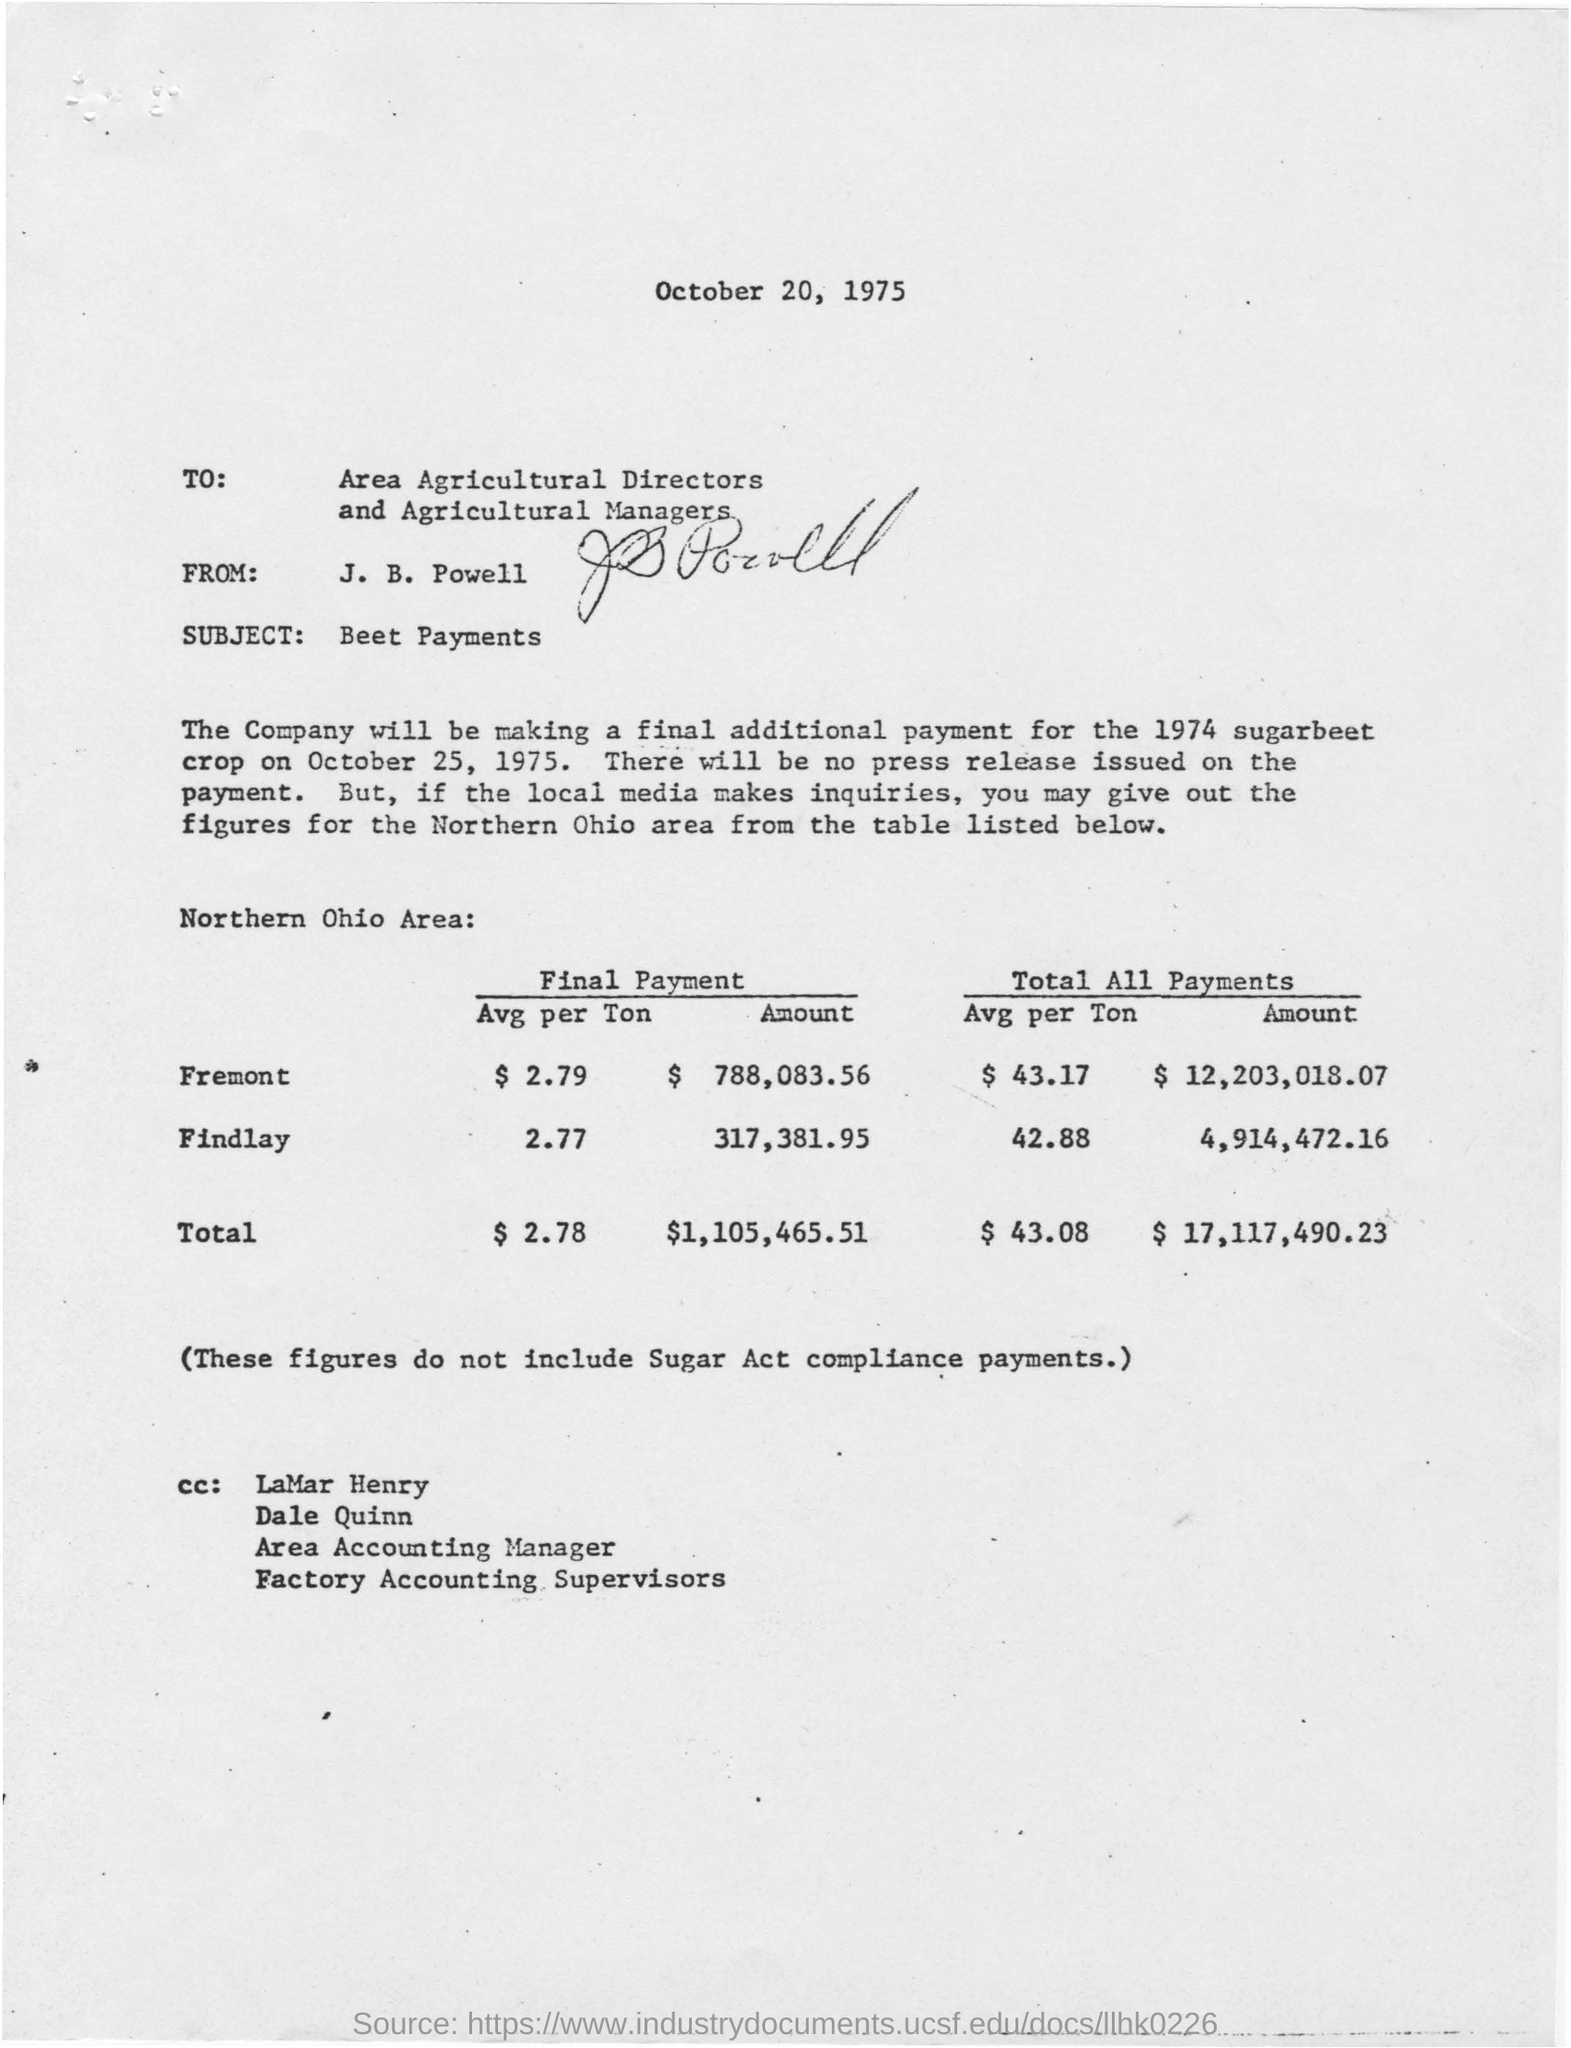List a handful of essential elements in this visual. The final payment for the sugar beet crop is due on October 25, 1975. The letter is dated October 20, 1975. The letter concerns Beet Payments. The table studied Northern Ohio Area. 